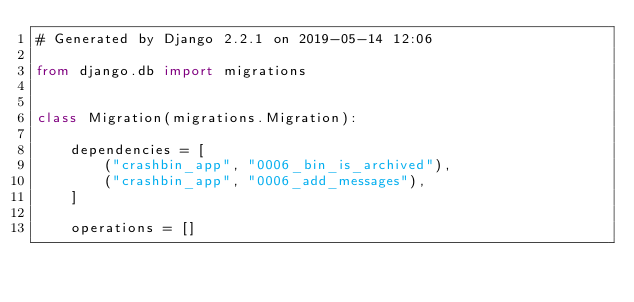Convert code to text. <code><loc_0><loc_0><loc_500><loc_500><_Python_># Generated by Django 2.2.1 on 2019-05-14 12:06

from django.db import migrations


class Migration(migrations.Migration):

    dependencies = [
        ("crashbin_app", "0006_bin_is_archived"),
        ("crashbin_app", "0006_add_messages"),
    ]

    operations = []
</code> 